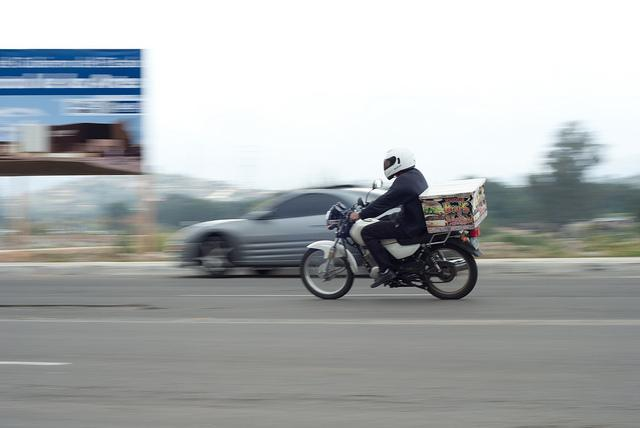How do motorcyclists carry gear?

Choices:
A) cart
B) string
C) luggage space
D) donkey luggage space 